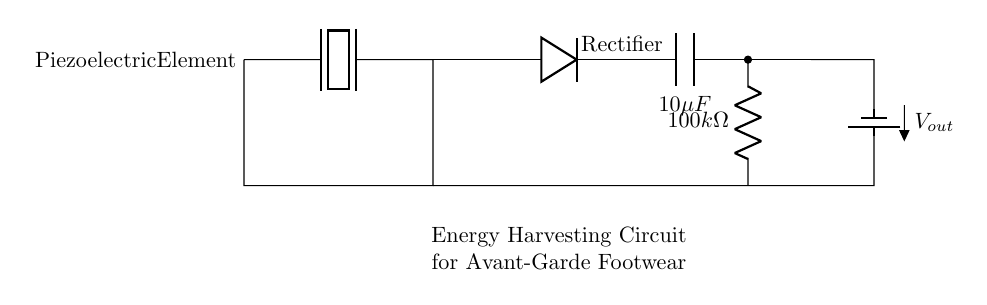What type of element is used for energy harvesting in this circuit? The diagram identifies a piezoelectric element specifically utilized for converting mechanical energy into electrical energy, and it is marked at the beginning of the circuit.
Answer: Piezoelectric What is the value of the capacitor in this circuit? The capacitor is denoted as C1 with a value of 10 microfarads, as labeled in the diagram next to the capacitor symbol.
Answer: 10 microfarads How many resistors are present in the circuit? The circuit contains one resistor (R1) labeled with a resistance of 100 kilohms; this is clearly indicated in the diagram.
Answer: One What component is used to rectify the voltage? The circuit includes a diode labeled as 'Rectifier' between the piezoelectric element and the capacitor, which serves to convert alternating current to direct current.
Answer: Diode What is the output voltage denoted in the circuit? The output voltage is represented at the battery symbol (labeled as Vout), but the exact numerical value is not specified in the diagram; it typically reflects the voltage generated from the piezoelectric element.
Answer: Vout What is the purpose of the resistor in this circuit? The resistor (R1) serves as a load, providing a pathway for current to flow and controlling the amount of current that can be delivered to the output; this function is critical for energy management in the circuit.
Answer: Load control 